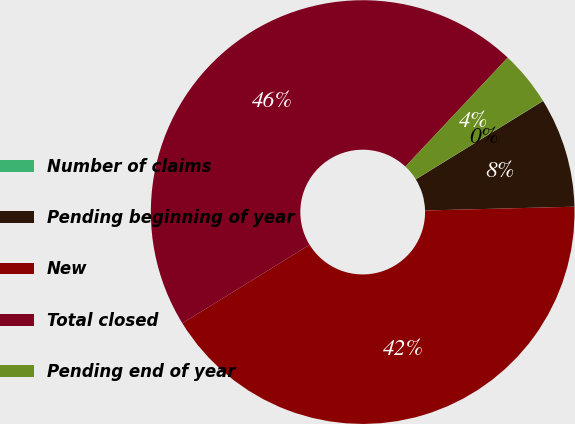<chart> <loc_0><loc_0><loc_500><loc_500><pie_chart><fcel>Number of claims<fcel>Pending beginning of year<fcel>New<fcel>Total closed<fcel>Pending end of year<nl><fcel>0.02%<fcel>8.38%<fcel>41.62%<fcel>45.8%<fcel>4.2%<nl></chart> 